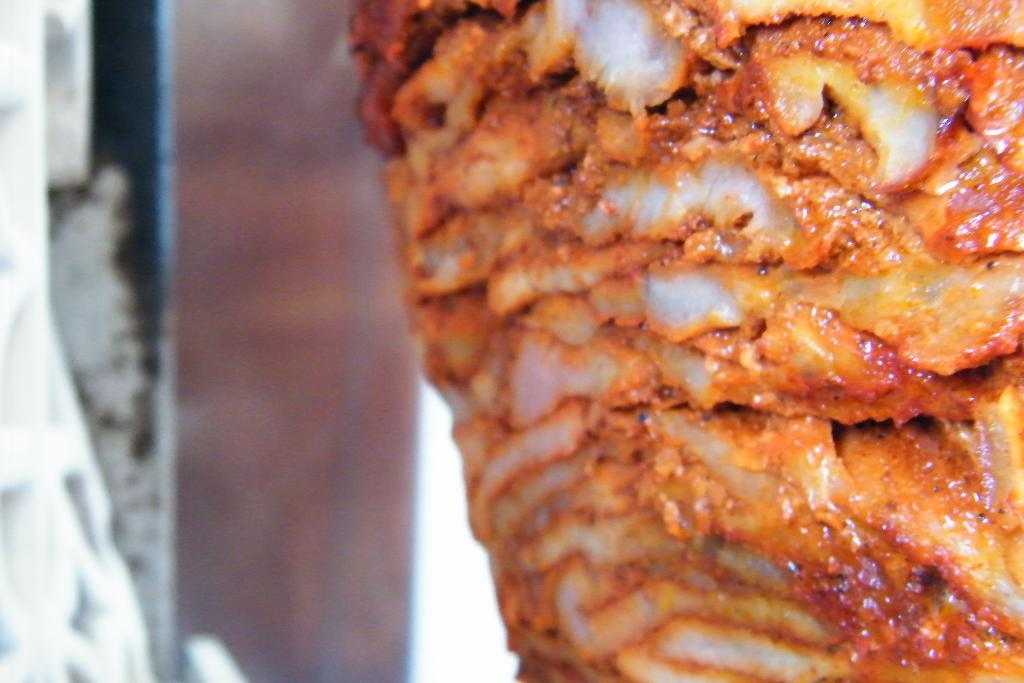What is the main subject of the image? There is a food item in the image. Can you describe the background of the image? The background of the image is blurred. What type of riddle can be solved by examining the food item in the image? There is no riddle present in the image, and therefore no such activity can be observed. 